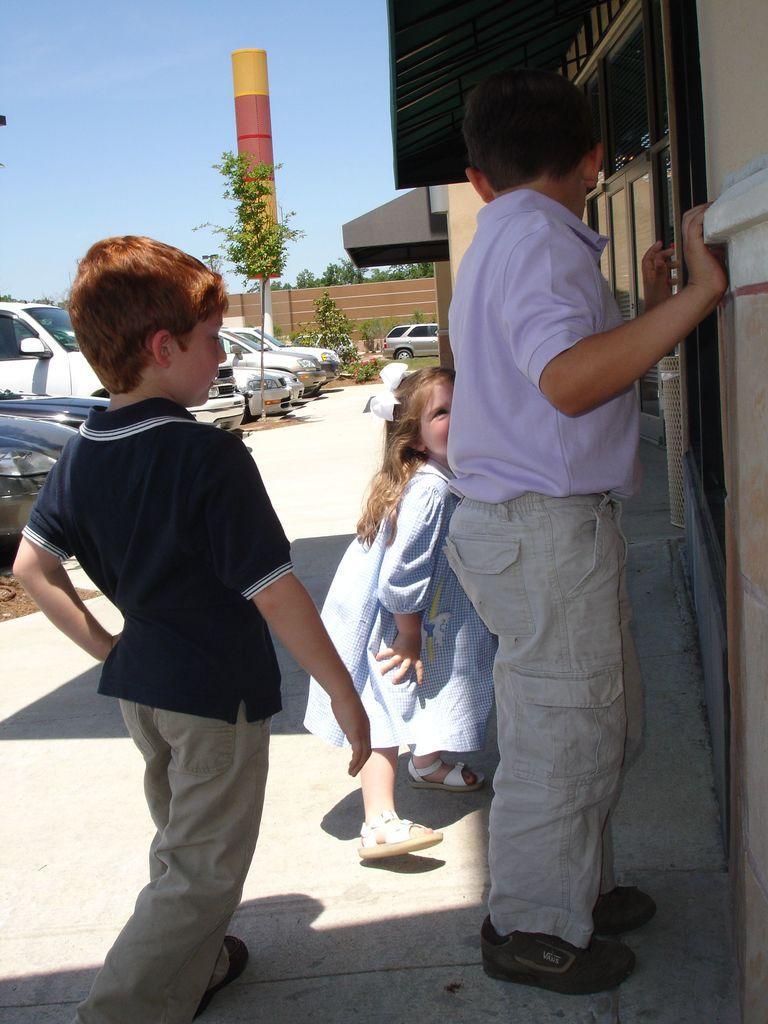Could you give a brief overview of what you see in this image? In the center of the image we can see three children standing. On the right there is a building. On the left there are cars. In the center there is a wall and a tree. In the background there is a tower and sky. 